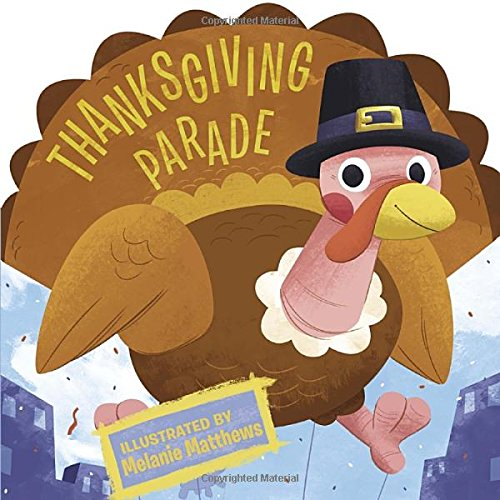Is this book related to Children's Books? Yes, this book is indeed a part of the Children's Books category, targeting young readers with its engaging illustrations and festive theme. 